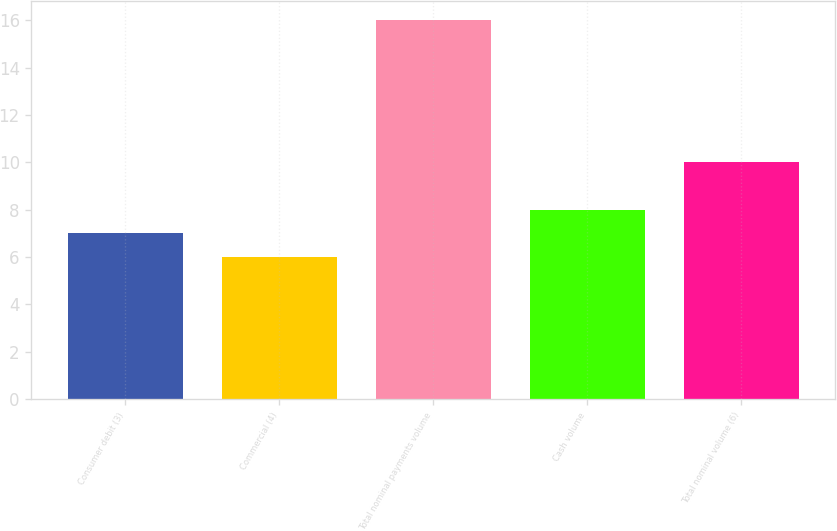<chart> <loc_0><loc_0><loc_500><loc_500><bar_chart><fcel>Consumer debit (3)<fcel>Commercial (4)<fcel>Total nominal payments volume<fcel>Cash volume<fcel>Total nominal volume (6)<nl><fcel>7<fcel>6<fcel>16<fcel>8<fcel>10<nl></chart> 